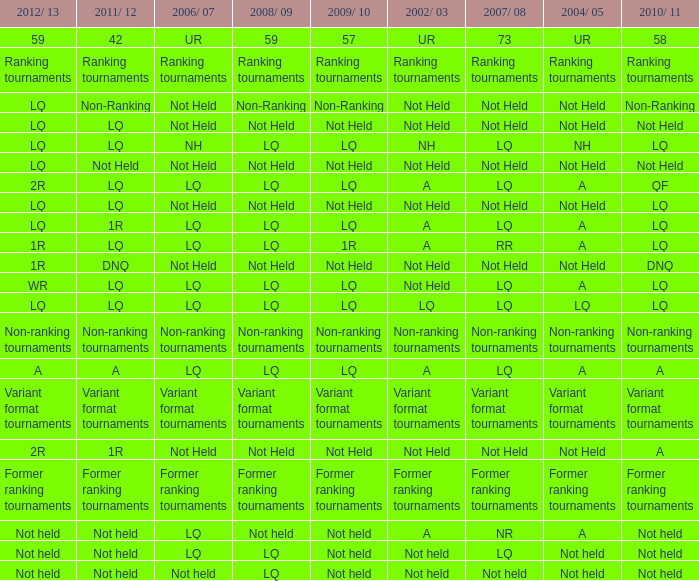Name the 2008/09 with 2004/05 of ranking tournaments Ranking tournaments. 